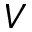Convert formula to latex. <formula><loc_0><loc_0><loc_500><loc_500>V</formula> 